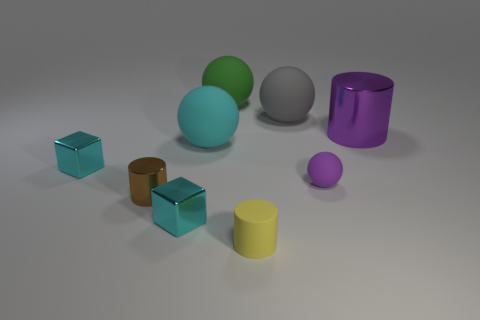There is a gray sphere that is the same size as the cyan rubber thing; what is it made of?
Your response must be concise. Rubber. There is a large cylinder; is its color the same as the matte sphere that is in front of the big cyan matte object?
Offer a terse response. Yes. What is the shape of the small object that is both behind the yellow matte cylinder and to the right of the big green ball?
Give a very brief answer. Sphere. What number of spheres have the same color as the large metallic thing?
Offer a very short reply. 1. Are there any rubber spheres in front of the large ball that is in front of the cylinder right of the purple ball?
Your answer should be compact. Yes. How big is the ball that is both on the right side of the green matte object and behind the big cyan thing?
Your answer should be very brief. Large. How many large green objects have the same material as the brown cylinder?
Your response must be concise. 0. How many blocks are either big metal things or tiny purple rubber things?
Ensure brevity in your answer.  0. There is a cyan thing that is behind the cyan metallic thing behind the cyan object that is in front of the tiny purple ball; how big is it?
Your answer should be compact. Large. The metal thing that is to the right of the brown shiny cylinder and in front of the large cylinder is what color?
Ensure brevity in your answer.  Cyan. 